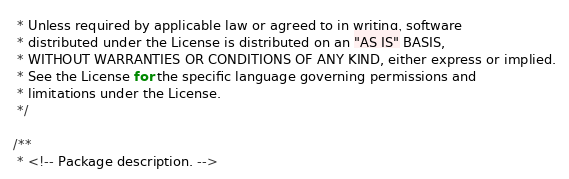<code> <loc_0><loc_0><loc_500><loc_500><_Java_> * Unless required by applicable law or agreed to in writing, software
 * distributed under the License is distributed on an "AS IS" BASIS,
 * WITHOUT WARRANTIES OR CONDITIONS OF ANY KIND, either express or implied.
 * See the License for the specific language governing permissions and
 * limitations under the License.
 */

/**
 * <!-- Package description. --></code> 